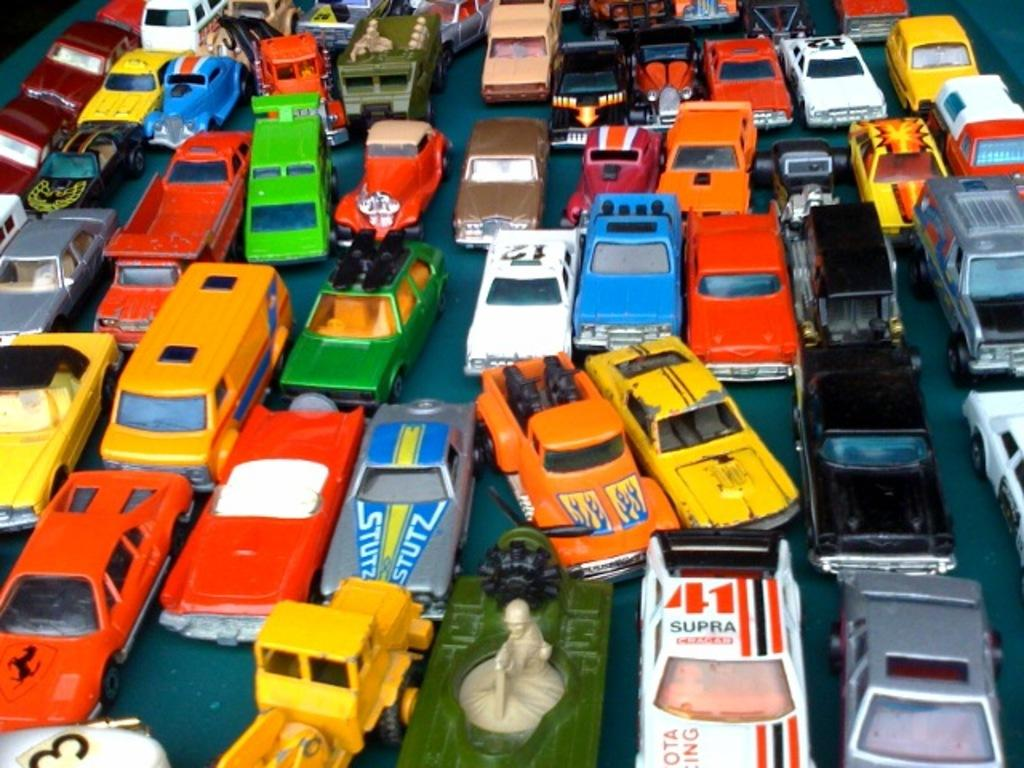<image>
Offer a succinct explanation of the picture presented. A bunch of toy cars including a white one with the number 41 and SUPRA on its roof. 